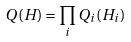<formula> <loc_0><loc_0><loc_500><loc_500>Q ( H ) = \prod _ { i } Q _ { i } ( H _ { i } )</formula> 